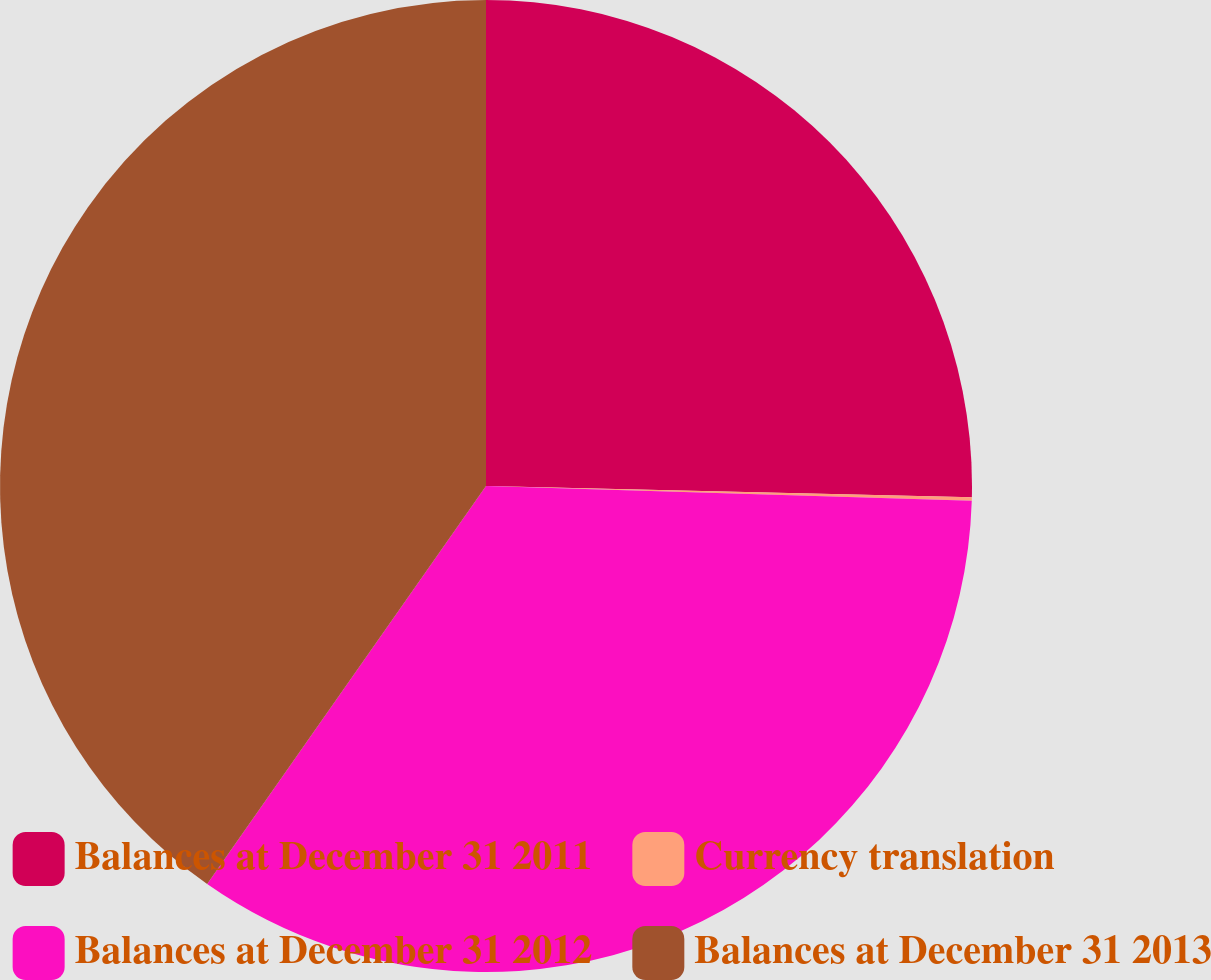Convert chart to OTSL. <chart><loc_0><loc_0><loc_500><loc_500><pie_chart><fcel>Balances at December 31 2011<fcel>Currency translation<fcel>Balances at December 31 2012<fcel>Balances at December 31 2013<nl><fcel>25.37%<fcel>0.11%<fcel>34.24%<fcel>40.27%<nl></chart> 